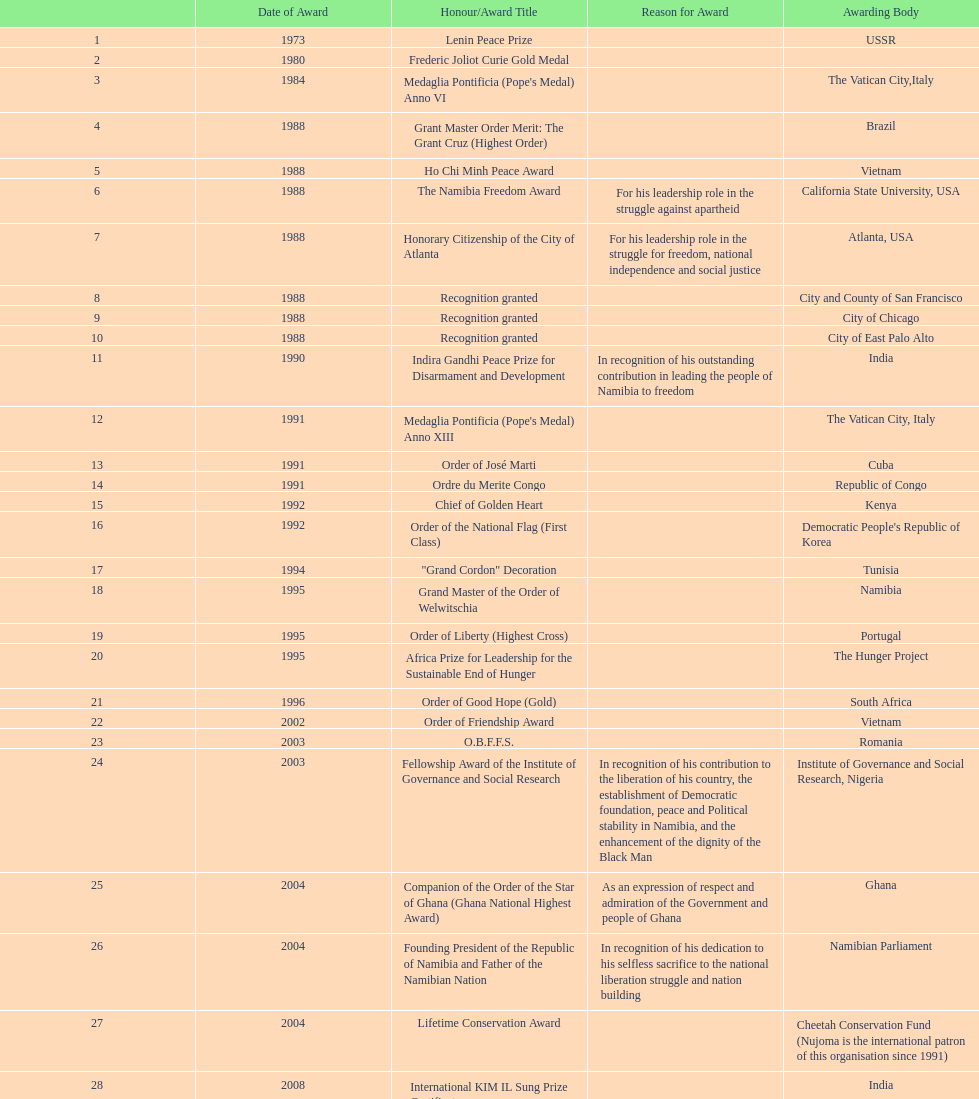What is the most recent award nujoma received? Sir Seretse Khama SADC Meda. 